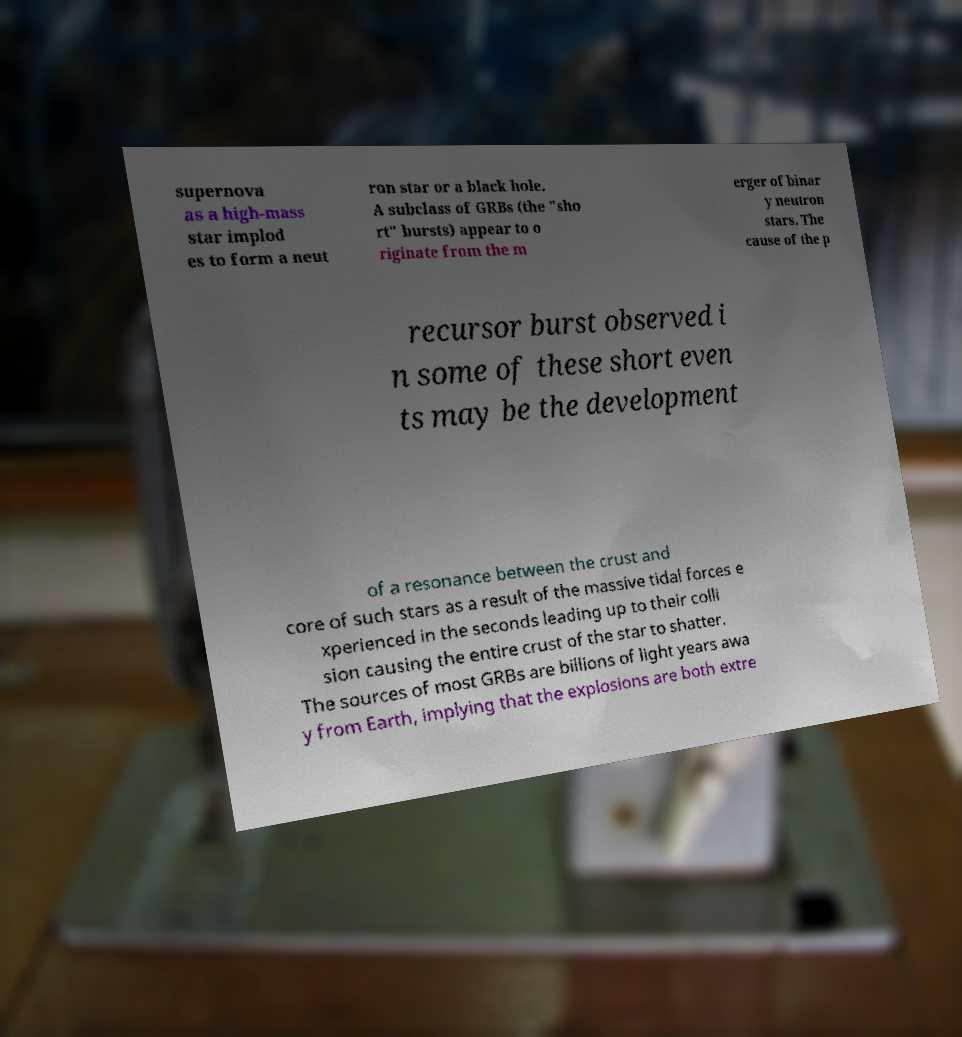I need the written content from this picture converted into text. Can you do that? supernova as a high-mass star implod es to form a neut ron star or a black hole. A subclass of GRBs (the "sho rt" bursts) appear to o riginate from the m erger of binar y neutron stars. The cause of the p recursor burst observed i n some of these short even ts may be the development of a resonance between the crust and core of such stars as a result of the massive tidal forces e xperienced in the seconds leading up to their colli sion causing the entire crust of the star to shatter. The sources of most GRBs are billions of light years awa y from Earth, implying that the explosions are both extre 